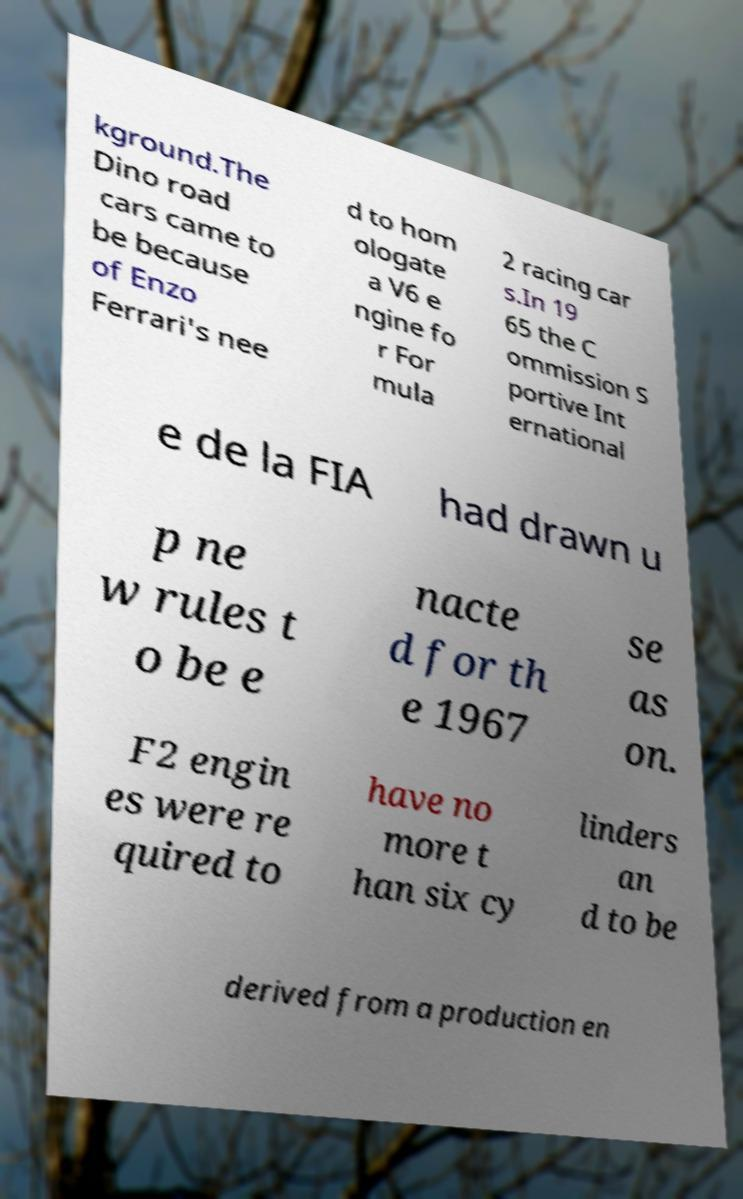Could you extract and type out the text from this image? kground.The Dino road cars came to be because of Enzo Ferrari's nee d to hom ologate a V6 e ngine fo r For mula 2 racing car s.In 19 65 the C ommission S portive Int ernational e de la FIA had drawn u p ne w rules t o be e nacte d for th e 1967 se as on. F2 engin es were re quired to have no more t han six cy linders an d to be derived from a production en 